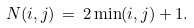<formula> <loc_0><loc_0><loc_500><loc_500>N ( i , j ) \, = \, 2 \min ( i , j ) + 1 .</formula> 